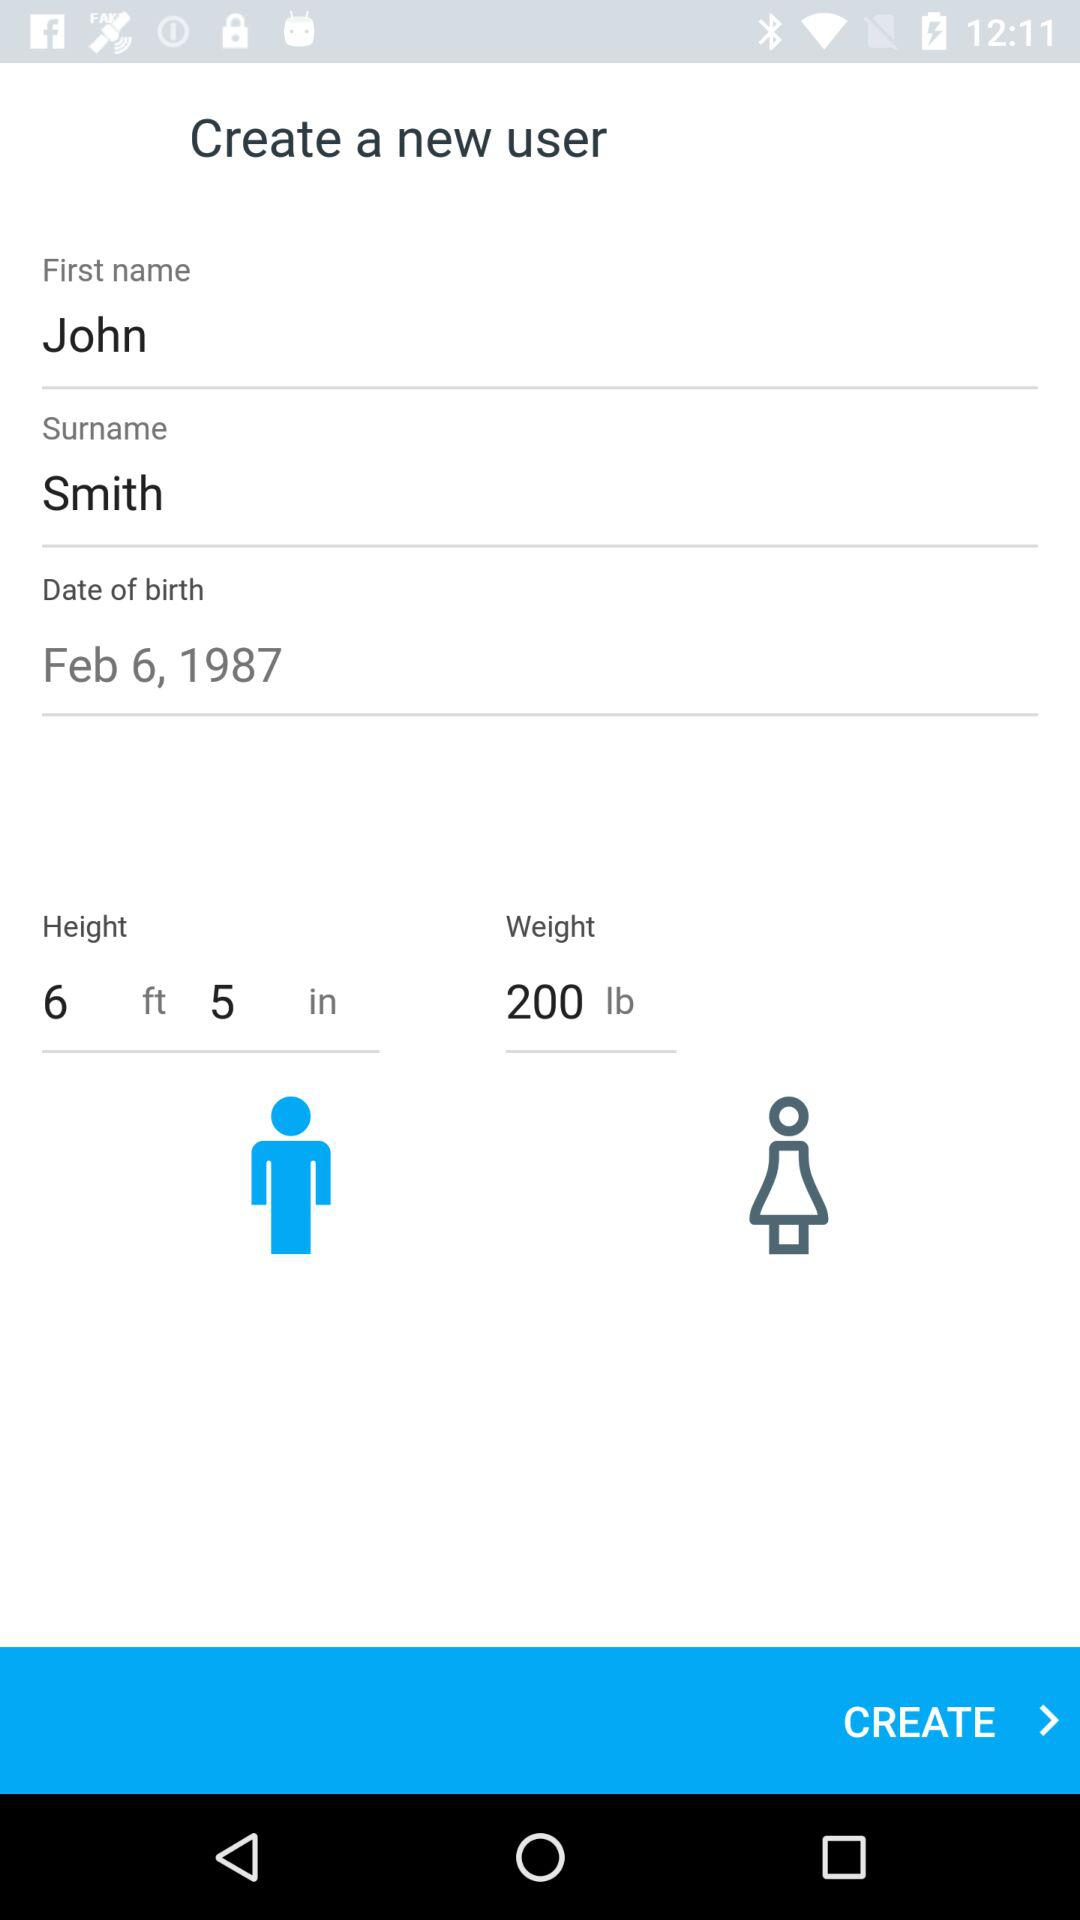What is the weight? The weight is 200 lbs. 